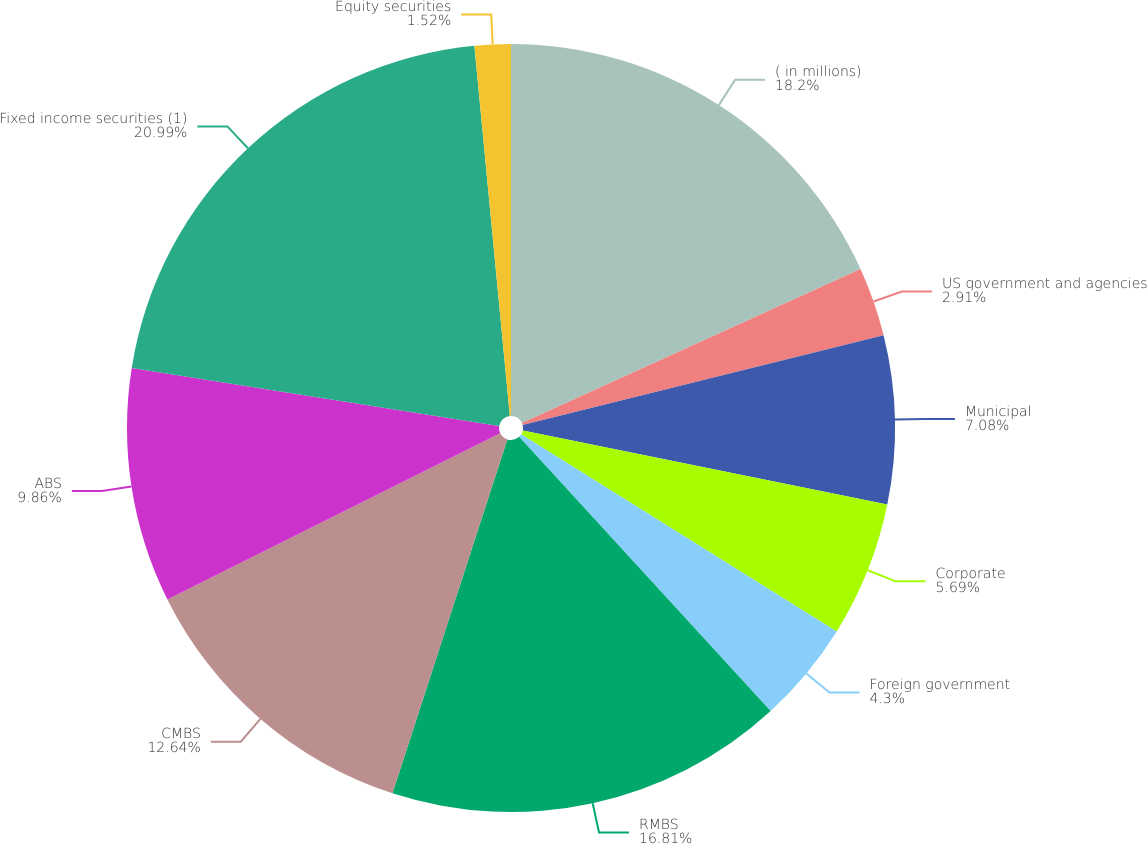Convert chart to OTSL. <chart><loc_0><loc_0><loc_500><loc_500><pie_chart><fcel>( in millions)<fcel>US government and agencies<fcel>Municipal<fcel>Corporate<fcel>Foreign government<fcel>RMBS<fcel>CMBS<fcel>ABS<fcel>Fixed income securities (1)<fcel>Equity securities<nl><fcel>18.2%<fcel>2.91%<fcel>7.08%<fcel>5.69%<fcel>4.3%<fcel>16.81%<fcel>12.64%<fcel>9.86%<fcel>20.98%<fcel>1.52%<nl></chart> 